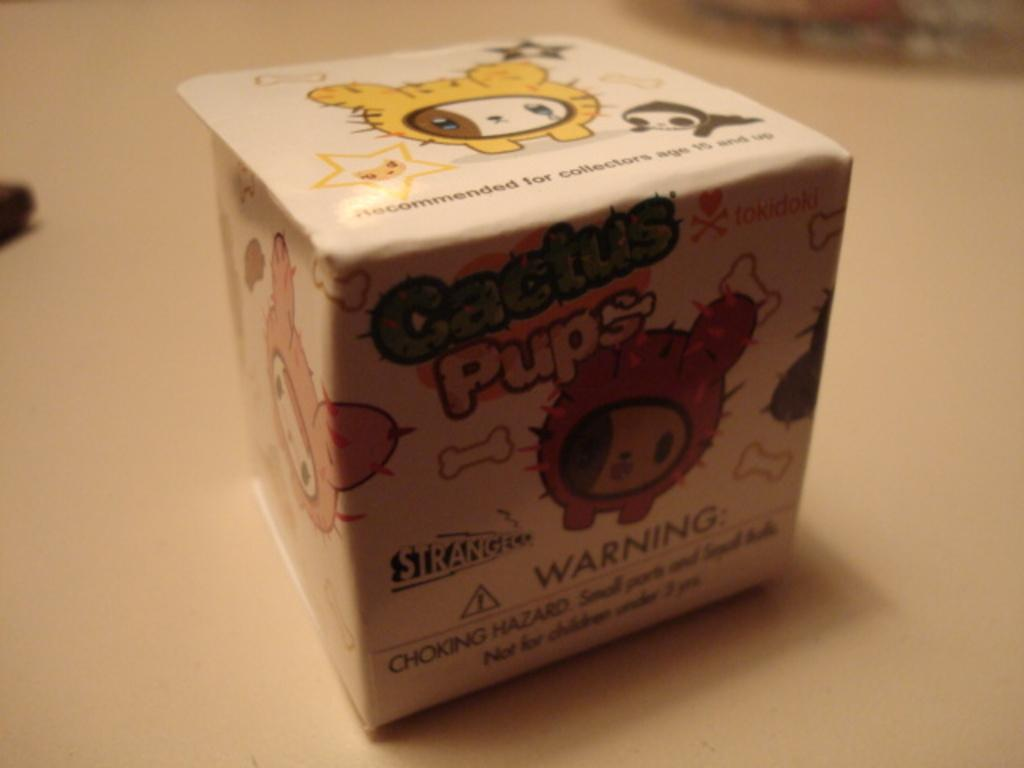<image>
Write a terse but informative summary of the picture. a small cubed square box that says cactus pups on it 